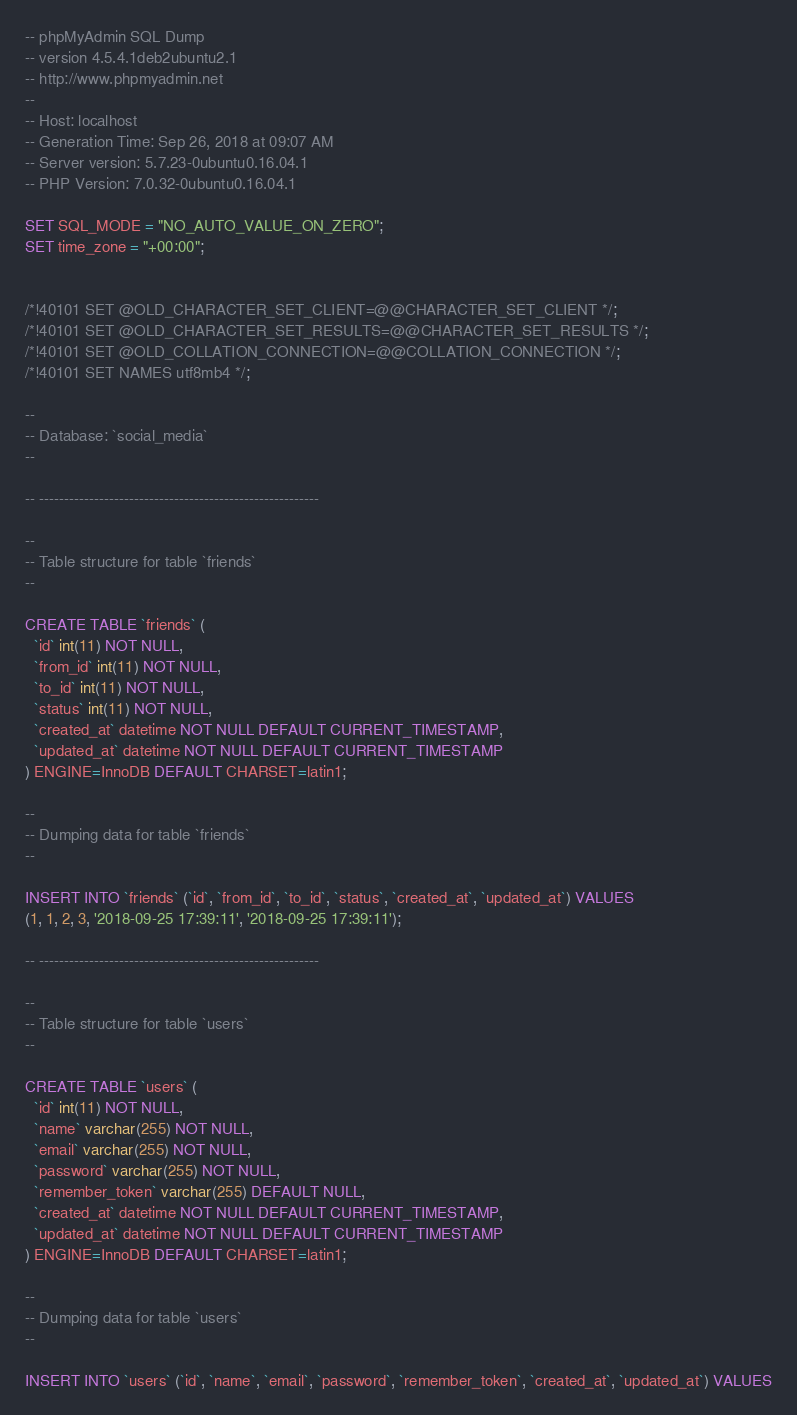<code> <loc_0><loc_0><loc_500><loc_500><_SQL_>-- phpMyAdmin SQL Dump
-- version 4.5.4.1deb2ubuntu2.1
-- http://www.phpmyadmin.net
--
-- Host: localhost
-- Generation Time: Sep 26, 2018 at 09:07 AM
-- Server version: 5.7.23-0ubuntu0.16.04.1
-- PHP Version: 7.0.32-0ubuntu0.16.04.1

SET SQL_MODE = "NO_AUTO_VALUE_ON_ZERO";
SET time_zone = "+00:00";


/*!40101 SET @OLD_CHARACTER_SET_CLIENT=@@CHARACTER_SET_CLIENT */;
/*!40101 SET @OLD_CHARACTER_SET_RESULTS=@@CHARACTER_SET_RESULTS */;
/*!40101 SET @OLD_COLLATION_CONNECTION=@@COLLATION_CONNECTION */;
/*!40101 SET NAMES utf8mb4 */;

--
-- Database: `social_media`
--

-- --------------------------------------------------------

--
-- Table structure for table `friends`
--

CREATE TABLE `friends` (
  `id` int(11) NOT NULL,
  `from_id` int(11) NOT NULL,
  `to_id` int(11) NOT NULL,
  `status` int(11) NOT NULL,
  `created_at` datetime NOT NULL DEFAULT CURRENT_TIMESTAMP,
  `updated_at` datetime NOT NULL DEFAULT CURRENT_TIMESTAMP
) ENGINE=InnoDB DEFAULT CHARSET=latin1;

--
-- Dumping data for table `friends`
--

INSERT INTO `friends` (`id`, `from_id`, `to_id`, `status`, `created_at`, `updated_at`) VALUES
(1, 1, 2, 3, '2018-09-25 17:39:11', '2018-09-25 17:39:11');

-- --------------------------------------------------------

--
-- Table structure for table `users`
--

CREATE TABLE `users` (
  `id` int(11) NOT NULL,
  `name` varchar(255) NOT NULL,
  `email` varchar(255) NOT NULL,
  `password` varchar(255) NOT NULL,
  `remember_token` varchar(255) DEFAULT NULL,
  `created_at` datetime NOT NULL DEFAULT CURRENT_TIMESTAMP,
  `updated_at` datetime NOT NULL DEFAULT CURRENT_TIMESTAMP
) ENGINE=InnoDB DEFAULT CHARSET=latin1;

--
-- Dumping data for table `users`
--

INSERT INTO `users` (`id`, `name`, `email`, `password`, `remember_token`, `created_at`, `updated_at`) VALUES</code> 